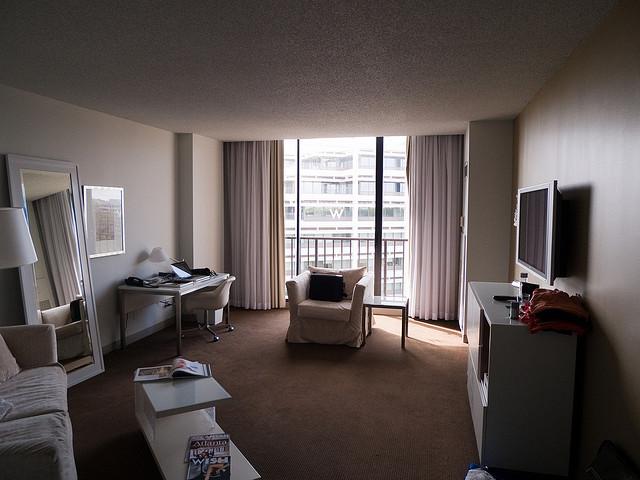Is this a rental house?
Concise answer only. Yes. Where is the mirror?
Quick response, please. Against wall. Is the room neat?
Write a very short answer. Yes. Is it day or night?
Write a very short answer. Day. 